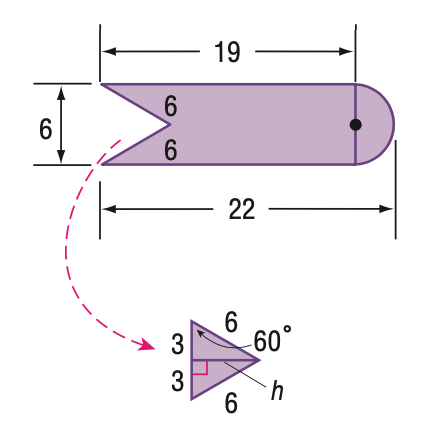Question: Find the area of the figure.
Choices:
A. 98.4
B. 112.5
C. 114
D. 128.1
Answer with the letter. Answer: B 